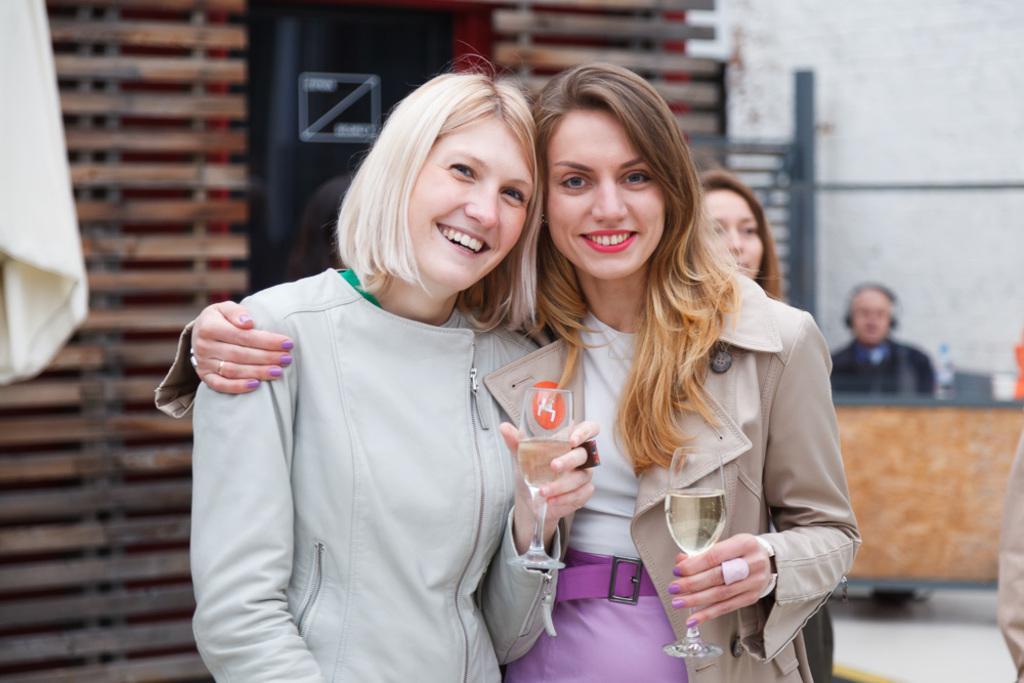How would you summarize this image in a sentence or two? In this picture I can see few women and I can see a woman holding the another woman with the hand and they are holding couple of glasses in their hands and I can see a man seated on the chair and he wore a headset and I can see a water bottle on the table and I can see a building entrance on the back and a closed umbrella on the left side. 